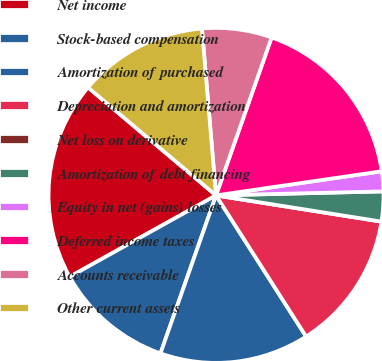Convert chart. <chart><loc_0><loc_0><loc_500><loc_500><pie_chart><fcel>Net income<fcel>Stock-based compensation<fcel>Amortization of purchased<fcel>Depreciation and amortization<fcel>Net loss on derivative<fcel>Amortization of debt financing<fcel>Equity in net (gains) losses<fcel>Deferred income taxes<fcel>Accounts receivable<fcel>Other current assets<nl><fcel>19.23%<fcel>11.54%<fcel>14.42%<fcel>13.46%<fcel>0.0%<fcel>2.88%<fcel>1.92%<fcel>17.31%<fcel>6.73%<fcel>12.5%<nl></chart> 